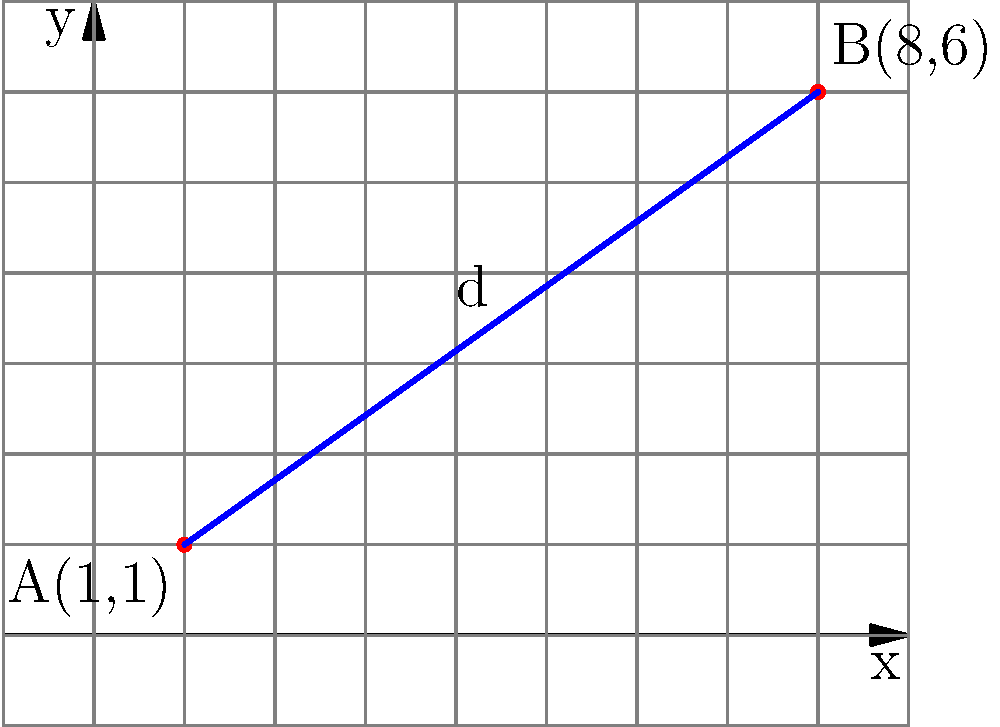In a choreography inspired by coordinate geometry, a ballet dancer performs a grand jeté leap from point A(1,1) to point B(8,6) on a coordinate plane representing the stage. Calculate the length of this leap, which is the distance between points A and B. Round your answer to two decimal places. To calculate the distance between two points on a coordinate plane, we can use the distance formula, which is derived from the Pythagorean theorem:

$$d = \sqrt{(x_2 - x_1)^2 + (y_2 - y_1)^2}$$

Where $(x_1, y_1)$ are the coordinates of the first point and $(x_2, y_2)$ are the coordinates of the second point.

Let's solve this step by step:

1) Identify the coordinates:
   Point A: $(x_1, y_1) = (1, 1)$
   Point B: $(x_2, y_2) = (8, 6)$

2) Plug these values into the distance formula:
   $$d = \sqrt{(8 - 1)^2 + (6 - 1)^2}$$

3) Simplify inside the parentheses:
   $$d = \sqrt{7^2 + 5^2}$$

4) Calculate the squares:
   $$d = \sqrt{49 + 25}$$

5) Add inside the square root:
   $$d = \sqrt{74}$$

6) Calculate the square root and round to two decimal places:
   $$d \approx 8.60$$

Therefore, the length of the grand jeté leap, or the distance between points A and B, is approximately 8.60 units.
Answer: 8.60 units 